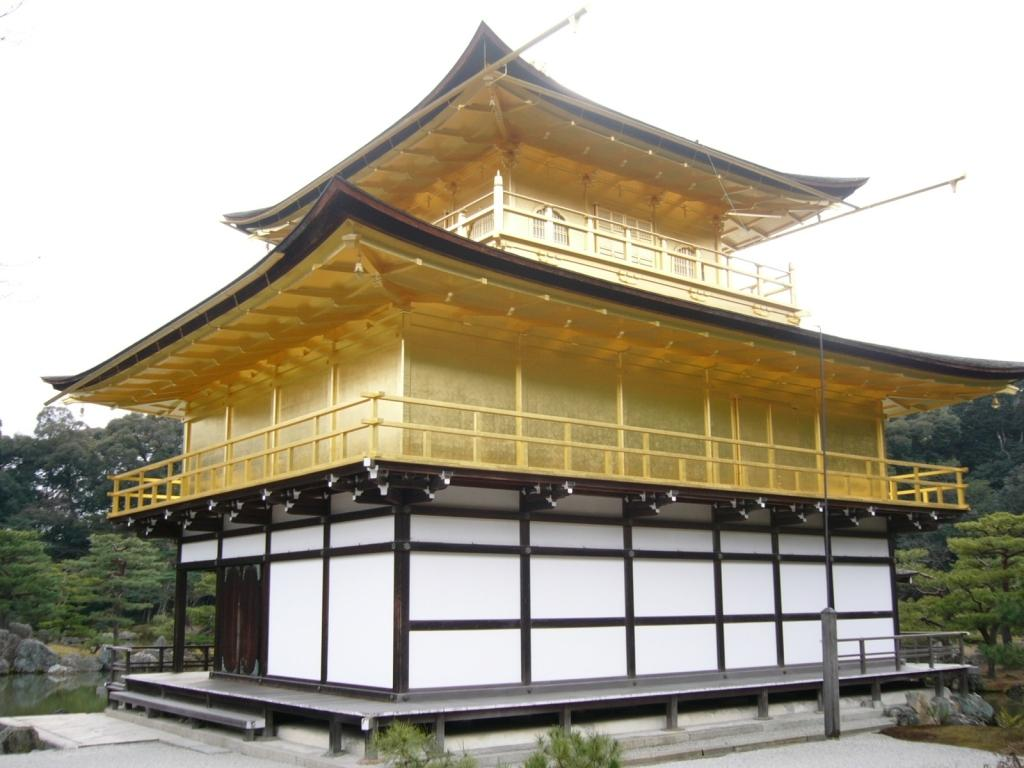What type of architecture can be seen in the image? There is ancient architecture in the image. What other elements are present in the image besides the architecture? There are rocks and plants visible in the image. What can be seen in the background of the image? There are trees and the sky visible in the background of the image. What type of nut is being used to access the account in the image? There is no mention of a nut or an account in the image; it features ancient architecture, rocks, plants, trees, and the sky. 